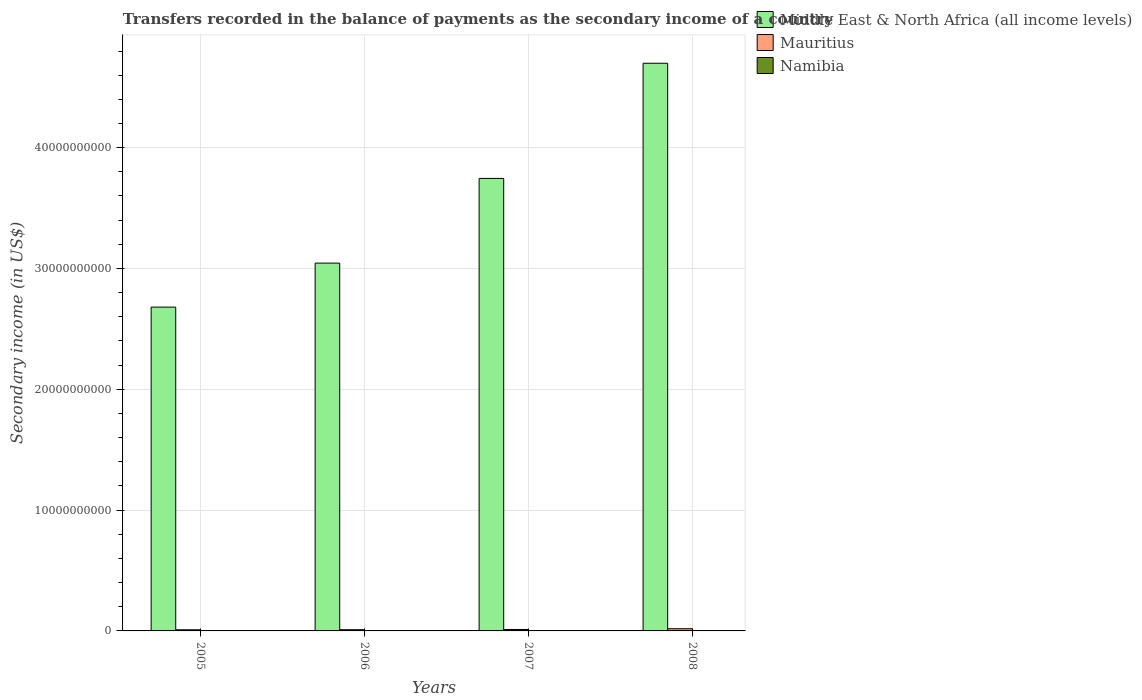How many groups of bars are there?
Ensure brevity in your answer.  4. How many bars are there on the 3rd tick from the left?
Provide a succinct answer. 3. What is the label of the 2nd group of bars from the left?
Ensure brevity in your answer.  2006. What is the secondary income of in Mauritius in 2006?
Provide a short and direct response. 1.02e+08. Across all years, what is the maximum secondary income of in Namibia?
Keep it short and to the point. 4.85e+06. Across all years, what is the minimum secondary income of in Namibia?
Provide a short and direct response. 3.78e+06. In which year was the secondary income of in Namibia maximum?
Give a very brief answer. 2005. What is the total secondary income of in Namibia in the graph?
Keep it short and to the point. 1.76e+07. What is the difference between the secondary income of in Middle East & North Africa (all income levels) in 2007 and that in 2008?
Provide a succinct answer. -9.53e+09. What is the difference between the secondary income of in Mauritius in 2007 and the secondary income of in Namibia in 2006?
Make the answer very short. 1.15e+08. What is the average secondary income of in Middle East & North Africa (all income levels) per year?
Your answer should be very brief. 3.54e+1. In the year 2005, what is the difference between the secondary income of in Mauritius and secondary income of in Namibia?
Offer a terse response. 9.06e+07. What is the ratio of the secondary income of in Mauritius in 2005 to that in 2008?
Offer a terse response. 0.52. Is the secondary income of in Middle East & North Africa (all income levels) in 2005 less than that in 2006?
Ensure brevity in your answer.  Yes. What is the difference between the highest and the second highest secondary income of in Namibia?
Offer a very short reply. 2.67e+05. What is the difference between the highest and the lowest secondary income of in Middle East & North Africa (all income levels)?
Ensure brevity in your answer.  2.02e+1. In how many years, is the secondary income of in Middle East & North Africa (all income levels) greater than the average secondary income of in Middle East & North Africa (all income levels) taken over all years?
Your answer should be compact. 2. Is the sum of the secondary income of in Mauritius in 2006 and 2007 greater than the maximum secondary income of in Namibia across all years?
Ensure brevity in your answer.  Yes. What does the 2nd bar from the left in 2008 represents?
Give a very brief answer. Mauritius. What does the 2nd bar from the right in 2008 represents?
Provide a short and direct response. Mauritius. What is the difference between two consecutive major ticks on the Y-axis?
Make the answer very short. 1.00e+1. Are the values on the major ticks of Y-axis written in scientific E-notation?
Provide a short and direct response. No. Does the graph contain grids?
Keep it short and to the point. Yes. What is the title of the graph?
Make the answer very short. Transfers recorded in the balance of payments as the secondary income of a country. What is the label or title of the X-axis?
Offer a very short reply. Years. What is the label or title of the Y-axis?
Give a very brief answer. Secondary income (in US$). What is the Secondary income (in US$) in Middle East & North Africa (all income levels) in 2005?
Provide a succinct answer. 2.68e+1. What is the Secondary income (in US$) in Mauritius in 2005?
Give a very brief answer. 9.54e+07. What is the Secondary income (in US$) in Namibia in 2005?
Your response must be concise. 4.85e+06. What is the Secondary income (in US$) of Middle East & North Africa (all income levels) in 2006?
Give a very brief answer. 3.04e+1. What is the Secondary income (in US$) of Mauritius in 2006?
Your answer should be very brief. 1.02e+08. What is the Secondary income (in US$) in Namibia in 2006?
Ensure brevity in your answer.  4.58e+06. What is the Secondary income (in US$) of Middle East & North Africa (all income levels) in 2007?
Keep it short and to the point. 3.75e+1. What is the Secondary income (in US$) in Mauritius in 2007?
Provide a short and direct response. 1.20e+08. What is the Secondary income (in US$) in Namibia in 2007?
Your response must be concise. 4.39e+06. What is the Secondary income (in US$) of Middle East & North Africa (all income levels) in 2008?
Your answer should be compact. 4.70e+1. What is the Secondary income (in US$) of Mauritius in 2008?
Your response must be concise. 1.82e+08. What is the Secondary income (in US$) in Namibia in 2008?
Your response must be concise. 3.78e+06. Across all years, what is the maximum Secondary income (in US$) in Middle East & North Africa (all income levels)?
Keep it short and to the point. 4.70e+1. Across all years, what is the maximum Secondary income (in US$) of Mauritius?
Make the answer very short. 1.82e+08. Across all years, what is the maximum Secondary income (in US$) in Namibia?
Keep it short and to the point. 4.85e+06. Across all years, what is the minimum Secondary income (in US$) of Middle East & North Africa (all income levels)?
Give a very brief answer. 2.68e+1. Across all years, what is the minimum Secondary income (in US$) of Mauritius?
Keep it short and to the point. 9.54e+07. Across all years, what is the minimum Secondary income (in US$) of Namibia?
Ensure brevity in your answer.  3.78e+06. What is the total Secondary income (in US$) of Middle East & North Africa (all income levels) in the graph?
Your response must be concise. 1.42e+11. What is the total Secondary income (in US$) in Mauritius in the graph?
Keep it short and to the point. 4.99e+08. What is the total Secondary income (in US$) in Namibia in the graph?
Your answer should be compact. 1.76e+07. What is the difference between the Secondary income (in US$) of Middle East & North Africa (all income levels) in 2005 and that in 2006?
Offer a very short reply. -3.64e+09. What is the difference between the Secondary income (in US$) of Mauritius in 2005 and that in 2006?
Make the answer very short. -6.65e+06. What is the difference between the Secondary income (in US$) of Namibia in 2005 and that in 2006?
Your answer should be compact. 2.67e+05. What is the difference between the Secondary income (in US$) of Middle East & North Africa (all income levels) in 2005 and that in 2007?
Provide a short and direct response. -1.07e+1. What is the difference between the Secondary income (in US$) of Mauritius in 2005 and that in 2007?
Keep it short and to the point. -2.45e+07. What is the difference between the Secondary income (in US$) in Namibia in 2005 and that in 2007?
Offer a very short reply. 4.64e+05. What is the difference between the Secondary income (in US$) in Middle East & North Africa (all income levels) in 2005 and that in 2008?
Ensure brevity in your answer.  -2.02e+1. What is the difference between the Secondary income (in US$) in Mauritius in 2005 and that in 2008?
Offer a very short reply. -8.65e+07. What is the difference between the Secondary income (in US$) of Namibia in 2005 and that in 2008?
Make the answer very short. 1.07e+06. What is the difference between the Secondary income (in US$) in Middle East & North Africa (all income levels) in 2006 and that in 2007?
Offer a terse response. -7.01e+09. What is the difference between the Secondary income (in US$) in Mauritius in 2006 and that in 2007?
Make the answer very short. -1.78e+07. What is the difference between the Secondary income (in US$) in Namibia in 2006 and that in 2007?
Give a very brief answer. 1.97e+05. What is the difference between the Secondary income (in US$) in Middle East & North Africa (all income levels) in 2006 and that in 2008?
Make the answer very short. -1.65e+1. What is the difference between the Secondary income (in US$) in Mauritius in 2006 and that in 2008?
Provide a succinct answer. -7.99e+07. What is the difference between the Secondary income (in US$) of Namibia in 2006 and that in 2008?
Make the answer very short. 7.98e+05. What is the difference between the Secondary income (in US$) of Middle East & North Africa (all income levels) in 2007 and that in 2008?
Your answer should be very brief. -9.53e+09. What is the difference between the Secondary income (in US$) of Mauritius in 2007 and that in 2008?
Your answer should be compact. -6.21e+07. What is the difference between the Secondary income (in US$) in Namibia in 2007 and that in 2008?
Provide a succinct answer. 6.01e+05. What is the difference between the Secondary income (in US$) of Middle East & North Africa (all income levels) in 2005 and the Secondary income (in US$) of Mauritius in 2006?
Give a very brief answer. 2.67e+1. What is the difference between the Secondary income (in US$) in Middle East & North Africa (all income levels) in 2005 and the Secondary income (in US$) in Namibia in 2006?
Offer a terse response. 2.68e+1. What is the difference between the Secondary income (in US$) of Mauritius in 2005 and the Secondary income (in US$) of Namibia in 2006?
Offer a terse response. 9.09e+07. What is the difference between the Secondary income (in US$) in Middle East & North Africa (all income levels) in 2005 and the Secondary income (in US$) in Mauritius in 2007?
Give a very brief answer. 2.67e+1. What is the difference between the Secondary income (in US$) in Middle East & North Africa (all income levels) in 2005 and the Secondary income (in US$) in Namibia in 2007?
Offer a very short reply. 2.68e+1. What is the difference between the Secondary income (in US$) of Mauritius in 2005 and the Secondary income (in US$) of Namibia in 2007?
Your response must be concise. 9.11e+07. What is the difference between the Secondary income (in US$) in Middle East & North Africa (all income levels) in 2005 and the Secondary income (in US$) in Mauritius in 2008?
Your response must be concise. 2.66e+1. What is the difference between the Secondary income (in US$) of Middle East & North Africa (all income levels) in 2005 and the Secondary income (in US$) of Namibia in 2008?
Give a very brief answer. 2.68e+1. What is the difference between the Secondary income (in US$) in Mauritius in 2005 and the Secondary income (in US$) in Namibia in 2008?
Give a very brief answer. 9.17e+07. What is the difference between the Secondary income (in US$) of Middle East & North Africa (all income levels) in 2006 and the Secondary income (in US$) of Mauritius in 2007?
Give a very brief answer. 3.03e+1. What is the difference between the Secondary income (in US$) in Middle East & North Africa (all income levels) in 2006 and the Secondary income (in US$) in Namibia in 2007?
Offer a very short reply. 3.04e+1. What is the difference between the Secondary income (in US$) in Mauritius in 2006 and the Secondary income (in US$) in Namibia in 2007?
Offer a very short reply. 9.77e+07. What is the difference between the Secondary income (in US$) in Middle East & North Africa (all income levels) in 2006 and the Secondary income (in US$) in Mauritius in 2008?
Ensure brevity in your answer.  3.03e+1. What is the difference between the Secondary income (in US$) in Middle East & North Africa (all income levels) in 2006 and the Secondary income (in US$) in Namibia in 2008?
Give a very brief answer. 3.04e+1. What is the difference between the Secondary income (in US$) of Mauritius in 2006 and the Secondary income (in US$) of Namibia in 2008?
Provide a short and direct response. 9.83e+07. What is the difference between the Secondary income (in US$) in Middle East & North Africa (all income levels) in 2007 and the Secondary income (in US$) in Mauritius in 2008?
Keep it short and to the point. 3.73e+1. What is the difference between the Secondary income (in US$) of Middle East & North Africa (all income levels) in 2007 and the Secondary income (in US$) of Namibia in 2008?
Your response must be concise. 3.75e+1. What is the difference between the Secondary income (in US$) in Mauritius in 2007 and the Secondary income (in US$) in Namibia in 2008?
Your answer should be very brief. 1.16e+08. What is the average Secondary income (in US$) of Middle East & North Africa (all income levels) per year?
Provide a succinct answer. 3.54e+1. What is the average Secondary income (in US$) in Mauritius per year?
Ensure brevity in your answer.  1.25e+08. What is the average Secondary income (in US$) of Namibia per year?
Provide a succinct answer. 4.40e+06. In the year 2005, what is the difference between the Secondary income (in US$) of Middle East & North Africa (all income levels) and Secondary income (in US$) of Mauritius?
Ensure brevity in your answer.  2.67e+1. In the year 2005, what is the difference between the Secondary income (in US$) in Middle East & North Africa (all income levels) and Secondary income (in US$) in Namibia?
Keep it short and to the point. 2.68e+1. In the year 2005, what is the difference between the Secondary income (in US$) in Mauritius and Secondary income (in US$) in Namibia?
Your answer should be compact. 9.06e+07. In the year 2006, what is the difference between the Secondary income (in US$) in Middle East & North Africa (all income levels) and Secondary income (in US$) in Mauritius?
Make the answer very short. 3.03e+1. In the year 2006, what is the difference between the Secondary income (in US$) of Middle East & North Africa (all income levels) and Secondary income (in US$) of Namibia?
Your response must be concise. 3.04e+1. In the year 2006, what is the difference between the Secondary income (in US$) in Mauritius and Secondary income (in US$) in Namibia?
Provide a succinct answer. 9.75e+07. In the year 2007, what is the difference between the Secondary income (in US$) of Middle East & North Africa (all income levels) and Secondary income (in US$) of Mauritius?
Your answer should be very brief. 3.73e+1. In the year 2007, what is the difference between the Secondary income (in US$) in Middle East & North Africa (all income levels) and Secondary income (in US$) in Namibia?
Provide a succinct answer. 3.75e+1. In the year 2007, what is the difference between the Secondary income (in US$) in Mauritius and Secondary income (in US$) in Namibia?
Offer a very short reply. 1.16e+08. In the year 2008, what is the difference between the Secondary income (in US$) of Middle East & North Africa (all income levels) and Secondary income (in US$) of Mauritius?
Your response must be concise. 4.68e+1. In the year 2008, what is the difference between the Secondary income (in US$) in Middle East & North Africa (all income levels) and Secondary income (in US$) in Namibia?
Your answer should be compact. 4.70e+1. In the year 2008, what is the difference between the Secondary income (in US$) in Mauritius and Secondary income (in US$) in Namibia?
Your response must be concise. 1.78e+08. What is the ratio of the Secondary income (in US$) of Middle East & North Africa (all income levels) in 2005 to that in 2006?
Provide a succinct answer. 0.88. What is the ratio of the Secondary income (in US$) of Mauritius in 2005 to that in 2006?
Your answer should be very brief. 0.93. What is the ratio of the Secondary income (in US$) in Namibia in 2005 to that in 2006?
Your response must be concise. 1.06. What is the ratio of the Secondary income (in US$) of Middle East & North Africa (all income levels) in 2005 to that in 2007?
Offer a very short reply. 0.72. What is the ratio of the Secondary income (in US$) in Mauritius in 2005 to that in 2007?
Keep it short and to the point. 0.8. What is the ratio of the Secondary income (in US$) of Namibia in 2005 to that in 2007?
Your answer should be compact. 1.11. What is the ratio of the Secondary income (in US$) of Middle East & North Africa (all income levels) in 2005 to that in 2008?
Provide a short and direct response. 0.57. What is the ratio of the Secondary income (in US$) in Mauritius in 2005 to that in 2008?
Offer a terse response. 0.52. What is the ratio of the Secondary income (in US$) in Namibia in 2005 to that in 2008?
Offer a very short reply. 1.28. What is the ratio of the Secondary income (in US$) of Middle East & North Africa (all income levels) in 2006 to that in 2007?
Give a very brief answer. 0.81. What is the ratio of the Secondary income (in US$) in Mauritius in 2006 to that in 2007?
Your answer should be very brief. 0.85. What is the ratio of the Secondary income (in US$) of Namibia in 2006 to that in 2007?
Keep it short and to the point. 1.04. What is the ratio of the Secondary income (in US$) of Middle East & North Africa (all income levels) in 2006 to that in 2008?
Your answer should be very brief. 0.65. What is the ratio of the Secondary income (in US$) in Mauritius in 2006 to that in 2008?
Provide a succinct answer. 0.56. What is the ratio of the Secondary income (in US$) in Namibia in 2006 to that in 2008?
Provide a succinct answer. 1.21. What is the ratio of the Secondary income (in US$) of Middle East & North Africa (all income levels) in 2007 to that in 2008?
Your answer should be compact. 0.8. What is the ratio of the Secondary income (in US$) in Mauritius in 2007 to that in 2008?
Your answer should be compact. 0.66. What is the ratio of the Secondary income (in US$) in Namibia in 2007 to that in 2008?
Offer a very short reply. 1.16. What is the difference between the highest and the second highest Secondary income (in US$) of Middle East & North Africa (all income levels)?
Provide a succinct answer. 9.53e+09. What is the difference between the highest and the second highest Secondary income (in US$) in Mauritius?
Give a very brief answer. 6.21e+07. What is the difference between the highest and the second highest Secondary income (in US$) of Namibia?
Keep it short and to the point. 2.67e+05. What is the difference between the highest and the lowest Secondary income (in US$) of Middle East & North Africa (all income levels)?
Offer a terse response. 2.02e+1. What is the difference between the highest and the lowest Secondary income (in US$) in Mauritius?
Ensure brevity in your answer.  8.65e+07. What is the difference between the highest and the lowest Secondary income (in US$) of Namibia?
Provide a succinct answer. 1.07e+06. 